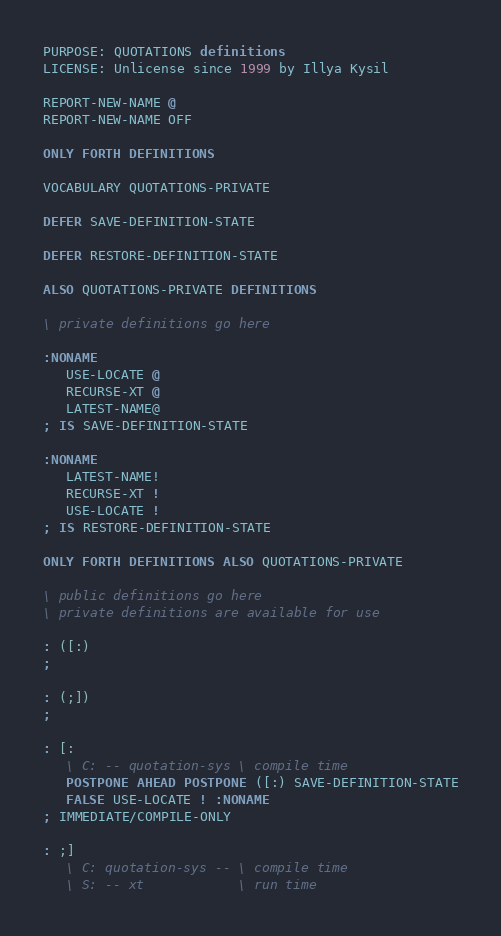Convert code to text. <code><loc_0><loc_0><loc_500><loc_500><_Forth_>PURPOSE: QUOTATIONS definitions
LICENSE: Unlicense since 1999 by Illya Kysil

REPORT-NEW-NAME @
REPORT-NEW-NAME OFF

ONLY FORTH DEFINITIONS

VOCABULARY QUOTATIONS-PRIVATE

DEFER SAVE-DEFINITION-STATE

DEFER RESTORE-DEFINITION-STATE

ALSO QUOTATIONS-PRIVATE DEFINITIONS

\ private definitions go here

:NONAME
   USE-LOCATE @
   RECURSE-XT @
   LATEST-NAME@
; IS SAVE-DEFINITION-STATE

:NONAME
   LATEST-NAME!
   RECURSE-XT !
   USE-LOCATE !
; IS RESTORE-DEFINITION-STATE

ONLY FORTH DEFINITIONS ALSO QUOTATIONS-PRIVATE

\ public definitions go here
\ private definitions are available for use

: ([:)
;

: (;])
;

: [:
   \ C: -- quotation-sys \ compile time
   POSTPONE AHEAD POSTPONE ([:) SAVE-DEFINITION-STATE
   FALSE USE-LOCATE ! :NONAME
; IMMEDIATE/COMPILE-ONLY

: ;]
   \ C: quotation-sys -- \ compile time
   \ S: -- xt            \ run time</code> 